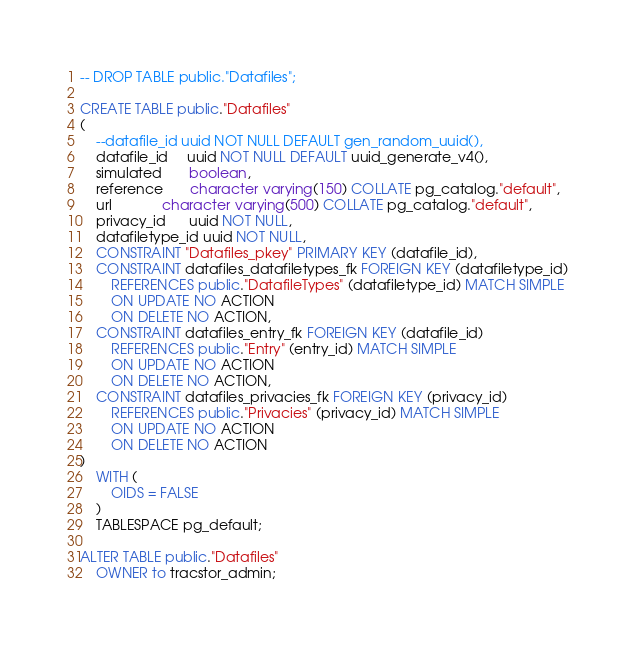Convert code to text. <code><loc_0><loc_0><loc_500><loc_500><_SQL_>
-- DROP TABLE public."Datafiles";

CREATE TABLE public."Datafiles"
(
    --datafile_id uuid NOT NULL DEFAULT gen_random_uuid(),
    datafile_id     uuid NOT NULL DEFAULT uuid_generate_v4(),
    simulated       boolean,
    reference       character varying(150) COLLATE pg_catalog."default",
    url             character varying(500) COLLATE pg_catalog."default",
    privacy_id      uuid NOT NULL,
    datafiletype_id uuid NOT NULL,
    CONSTRAINT "Datafiles_pkey" PRIMARY KEY (datafile_id),
    CONSTRAINT datafiles_datafiletypes_fk FOREIGN KEY (datafiletype_id)
        REFERENCES public."DatafileTypes" (datafiletype_id) MATCH SIMPLE
        ON UPDATE NO ACTION
        ON DELETE NO ACTION,
    CONSTRAINT datafiles_entry_fk FOREIGN KEY (datafile_id)
        REFERENCES public."Entry" (entry_id) MATCH SIMPLE
        ON UPDATE NO ACTION
        ON DELETE NO ACTION,
    CONSTRAINT datafiles_privacies_fk FOREIGN KEY (privacy_id)
        REFERENCES public."Privacies" (privacy_id) MATCH SIMPLE
        ON UPDATE NO ACTION
        ON DELETE NO ACTION
)
    WITH (
        OIDS = FALSE
    )
    TABLESPACE pg_default;

ALTER TABLE public."Datafiles"
    OWNER to tracstor_admin;</code> 